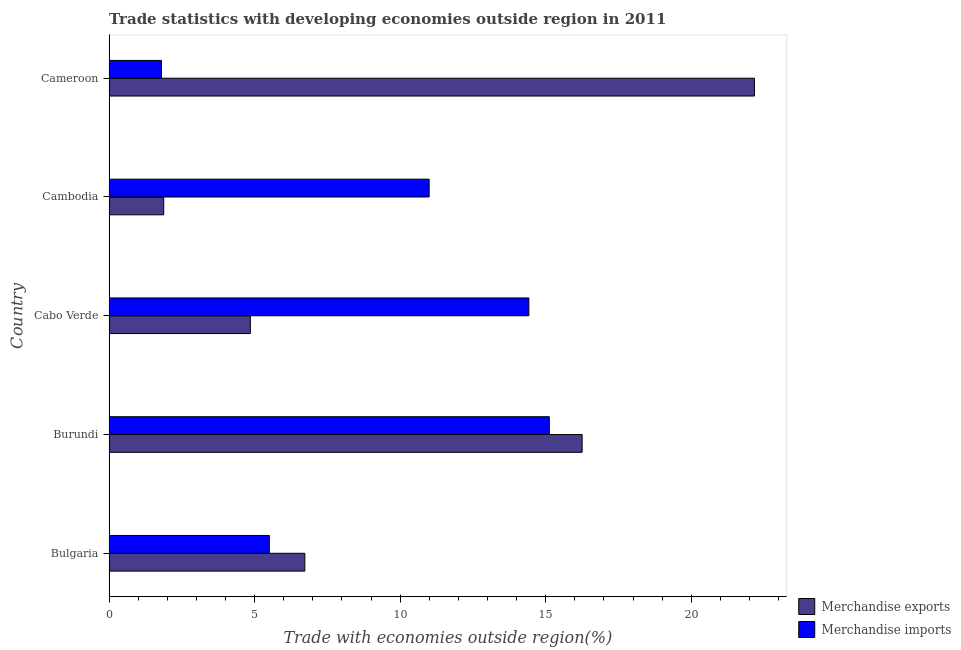How many groups of bars are there?
Your answer should be very brief. 5. Are the number of bars on each tick of the Y-axis equal?
Give a very brief answer. Yes. How many bars are there on the 1st tick from the top?
Your response must be concise. 2. How many bars are there on the 1st tick from the bottom?
Provide a short and direct response. 2. What is the label of the 4th group of bars from the top?
Provide a short and direct response. Burundi. What is the merchandise imports in Cambodia?
Provide a succinct answer. 11. Across all countries, what is the maximum merchandise exports?
Offer a very short reply. 22.17. Across all countries, what is the minimum merchandise exports?
Offer a terse response. 1.88. In which country was the merchandise exports maximum?
Keep it short and to the point. Cameroon. In which country was the merchandise imports minimum?
Your answer should be very brief. Cameroon. What is the total merchandise imports in the graph?
Make the answer very short. 47.85. What is the difference between the merchandise exports in Bulgaria and that in Cameroon?
Provide a short and direct response. -15.45. What is the difference between the merchandise exports in Cameroon and the merchandise imports in Cabo Verde?
Offer a very short reply. 7.75. What is the average merchandise imports per country?
Provide a succinct answer. 9.57. What is the difference between the merchandise exports and merchandise imports in Cambodia?
Make the answer very short. -9.12. In how many countries, is the merchandise exports greater than 7 %?
Your response must be concise. 2. What is the ratio of the merchandise exports in Burundi to that in Cambodia?
Provide a succinct answer. 8.66. Is the merchandise exports in Burundi less than that in Cameroon?
Make the answer very short. Yes. Is the difference between the merchandise imports in Burundi and Cambodia greater than the difference between the merchandise exports in Burundi and Cambodia?
Your response must be concise. No. What is the difference between the highest and the second highest merchandise exports?
Your answer should be very brief. 5.92. What is the difference between the highest and the lowest merchandise exports?
Your response must be concise. 20.29. Is the sum of the merchandise imports in Cabo Verde and Cameroon greater than the maximum merchandise exports across all countries?
Your answer should be compact. No. What does the 2nd bar from the top in Cambodia represents?
Offer a very short reply. Merchandise exports. What does the 2nd bar from the bottom in Bulgaria represents?
Offer a terse response. Merchandise imports. Where does the legend appear in the graph?
Your answer should be compact. Bottom right. How many legend labels are there?
Make the answer very short. 2. How are the legend labels stacked?
Give a very brief answer. Vertical. What is the title of the graph?
Provide a succinct answer. Trade statistics with developing economies outside region in 2011. What is the label or title of the X-axis?
Keep it short and to the point. Trade with economies outside region(%). What is the label or title of the Y-axis?
Your answer should be very brief. Country. What is the Trade with economies outside region(%) in Merchandise exports in Bulgaria?
Keep it short and to the point. 6.73. What is the Trade with economies outside region(%) in Merchandise imports in Bulgaria?
Ensure brevity in your answer.  5.51. What is the Trade with economies outside region(%) in Merchandise exports in Burundi?
Ensure brevity in your answer.  16.25. What is the Trade with economies outside region(%) in Merchandise imports in Burundi?
Your answer should be compact. 15.12. What is the Trade with economies outside region(%) in Merchandise exports in Cabo Verde?
Provide a short and direct response. 4.85. What is the Trade with economies outside region(%) in Merchandise imports in Cabo Verde?
Make the answer very short. 14.42. What is the Trade with economies outside region(%) of Merchandise exports in Cambodia?
Offer a terse response. 1.88. What is the Trade with economies outside region(%) of Merchandise imports in Cambodia?
Offer a very short reply. 11. What is the Trade with economies outside region(%) of Merchandise exports in Cameroon?
Keep it short and to the point. 22.17. What is the Trade with economies outside region(%) in Merchandise imports in Cameroon?
Your answer should be very brief. 1.8. Across all countries, what is the maximum Trade with economies outside region(%) in Merchandise exports?
Provide a short and direct response. 22.17. Across all countries, what is the maximum Trade with economies outside region(%) of Merchandise imports?
Your answer should be very brief. 15.12. Across all countries, what is the minimum Trade with economies outside region(%) in Merchandise exports?
Provide a short and direct response. 1.88. Across all countries, what is the minimum Trade with economies outside region(%) in Merchandise imports?
Give a very brief answer. 1.8. What is the total Trade with economies outside region(%) in Merchandise exports in the graph?
Your answer should be compact. 51.88. What is the total Trade with economies outside region(%) of Merchandise imports in the graph?
Your answer should be compact. 47.85. What is the difference between the Trade with economies outside region(%) of Merchandise exports in Bulgaria and that in Burundi?
Your response must be concise. -9.53. What is the difference between the Trade with economies outside region(%) of Merchandise imports in Bulgaria and that in Burundi?
Your answer should be very brief. -9.62. What is the difference between the Trade with economies outside region(%) in Merchandise exports in Bulgaria and that in Cabo Verde?
Provide a succinct answer. 1.87. What is the difference between the Trade with economies outside region(%) in Merchandise imports in Bulgaria and that in Cabo Verde?
Provide a succinct answer. -8.92. What is the difference between the Trade with economies outside region(%) in Merchandise exports in Bulgaria and that in Cambodia?
Provide a short and direct response. 4.85. What is the difference between the Trade with economies outside region(%) in Merchandise imports in Bulgaria and that in Cambodia?
Make the answer very short. -5.49. What is the difference between the Trade with economies outside region(%) of Merchandise exports in Bulgaria and that in Cameroon?
Provide a succinct answer. -15.45. What is the difference between the Trade with economies outside region(%) in Merchandise imports in Bulgaria and that in Cameroon?
Offer a very short reply. 3.71. What is the difference between the Trade with economies outside region(%) in Merchandise exports in Burundi and that in Cabo Verde?
Your response must be concise. 11.4. What is the difference between the Trade with economies outside region(%) of Merchandise imports in Burundi and that in Cabo Verde?
Make the answer very short. 0.7. What is the difference between the Trade with economies outside region(%) of Merchandise exports in Burundi and that in Cambodia?
Provide a succinct answer. 14.37. What is the difference between the Trade with economies outside region(%) of Merchandise imports in Burundi and that in Cambodia?
Make the answer very short. 4.13. What is the difference between the Trade with economies outside region(%) in Merchandise exports in Burundi and that in Cameroon?
Ensure brevity in your answer.  -5.92. What is the difference between the Trade with economies outside region(%) of Merchandise imports in Burundi and that in Cameroon?
Keep it short and to the point. 13.32. What is the difference between the Trade with economies outside region(%) in Merchandise exports in Cabo Verde and that in Cambodia?
Make the answer very short. 2.98. What is the difference between the Trade with economies outside region(%) in Merchandise imports in Cabo Verde and that in Cambodia?
Keep it short and to the point. 3.42. What is the difference between the Trade with economies outside region(%) of Merchandise exports in Cabo Verde and that in Cameroon?
Ensure brevity in your answer.  -17.32. What is the difference between the Trade with economies outside region(%) of Merchandise imports in Cabo Verde and that in Cameroon?
Offer a very short reply. 12.62. What is the difference between the Trade with economies outside region(%) of Merchandise exports in Cambodia and that in Cameroon?
Your response must be concise. -20.29. What is the difference between the Trade with economies outside region(%) of Merchandise imports in Cambodia and that in Cameroon?
Offer a very short reply. 9.2. What is the difference between the Trade with economies outside region(%) in Merchandise exports in Bulgaria and the Trade with economies outside region(%) in Merchandise imports in Burundi?
Your answer should be very brief. -8.4. What is the difference between the Trade with economies outside region(%) in Merchandise exports in Bulgaria and the Trade with economies outside region(%) in Merchandise imports in Cabo Verde?
Ensure brevity in your answer.  -7.7. What is the difference between the Trade with economies outside region(%) in Merchandise exports in Bulgaria and the Trade with economies outside region(%) in Merchandise imports in Cambodia?
Your answer should be compact. -4.27. What is the difference between the Trade with economies outside region(%) of Merchandise exports in Bulgaria and the Trade with economies outside region(%) of Merchandise imports in Cameroon?
Provide a succinct answer. 4.93. What is the difference between the Trade with economies outside region(%) of Merchandise exports in Burundi and the Trade with economies outside region(%) of Merchandise imports in Cabo Verde?
Offer a very short reply. 1.83. What is the difference between the Trade with economies outside region(%) in Merchandise exports in Burundi and the Trade with economies outside region(%) in Merchandise imports in Cambodia?
Make the answer very short. 5.26. What is the difference between the Trade with economies outside region(%) of Merchandise exports in Burundi and the Trade with economies outside region(%) of Merchandise imports in Cameroon?
Your answer should be very brief. 14.45. What is the difference between the Trade with economies outside region(%) in Merchandise exports in Cabo Verde and the Trade with economies outside region(%) in Merchandise imports in Cambodia?
Your answer should be very brief. -6.14. What is the difference between the Trade with economies outside region(%) of Merchandise exports in Cabo Verde and the Trade with economies outside region(%) of Merchandise imports in Cameroon?
Ensure brevity in your answer.  3.05. What is the difference between the Trade with economies outside region(%) of Merchandise exports in Cambodia and the Trade with economies outside region(%) of Merchandise imports in Cameroon?
Offer a terse response. 0.08. What is the average Trade with economies outside region(%) in Merchandise exports per country?
Provide a succinct answer. 10.38. What is the average Trade with economies outside region(%) of Merchandise imports per country?
Your answer should be compact. 9.57. What is the difference between the Trade with economies outside region(%) of Merchandise exports and Trade with economies outside region(%) of Merchandise imports in Bulgaria?
Offer a terse response. 1.22. What is the difference between the Trade with economies outside region(%) in Merchandise exports and Trade with economies outside region(%) in Merchandise imports in Burundi?
Ensure brevity in your answer.  1.13. What is the difference between the Trade with economies outside region(%) in Merchandise exports and Trade with economies outside region(%) in Merchandise imports in Cabo Verde?
Provide a short and direct response. -9.57. What is the difference between the Trade with economies outside region(%) in Merchandise exports and Trade with economies outside region(%) in Merchandise imports in Cambodia?
Your answer should be very brief. -9.12. What is the difference between the Trade with economies outside region(%) of Merchandise exports and Trade with economies outside region(%) of Merchandise imports in Cameroon?
Keep it short and to the point. 20.37. What is the ratio of the Trade with economies outside region(%) in Merchandise exports in Bulgaria to that in Burundi?
Your response must be concise. 0.41. What is the ratio of the Trade with economies outside region(%) in Merchandise imports in Bulgaria to that in Burundi?
Your answer should be compact. 0.36. What is the ratio of the Trade with economies outside region(%) of Merchandise exports in Bulgaria to that in Cabo Verde?
Provide a succinct answer. 1.39. What is the ratio of the Trade with economies outside region(%) of Merchandise imports in Bulgaria to that in Cabo Verde?
Make the answer very short. 0.38. What is the ratio of the Trade with economies outside region(%) of Merchandise exports in Bulgaria to that in Cambodia?
Give a very brief answer. 3.58. What is the ratio of the Trade with economies outside region(%) of Merchandise imports in Bulgaria to that in Cambodia?
Make the answer very short. 0.5. What is the ratio of the Trade with economies outside region(%) in Merchandise exports in Bulgaria to that in Cameroon?
Your response must be concise. 0.3. What is the ratio of the Trade with economies outside region(%) in Merchandise imports in Bulgaria to that in Cameroon?
Offer a terse response. 3.06. What is the ratio of the Trade with economies outside region(%) in Merchandise exports in Burundi to that in Cabo Verde?
Provide a succinct answer. 3.35. What is the ratio of the Trade with economies outside region(%) of Merchandise imports in Burundi to that in Cabo Verde?
Give a very brief answer. 1.05. What is the ratio of the Trade with economies outside region(%) in Merchandise exports in Burundi to that in Cambodia?
Make the answer very short. 8.66. What is the ratio of the Trade with economies outside region(%) in Merchandise imports in Burundi to that in Cambodia?
Offer a very short reply. 1.38. What is the ratio of the Trade with economies outside region(%) of Merchandise exports in Burundi to that in Cameroon?
Your answer should be compact. 0.73. What is the ratio of the Trade with economies outside region(%) in Merchandise imports in Burundi to that in Cameroon?
Offer a terse response. 8.4. What is the ratio of the Trade with economies outside region(%) in Merchandise exports in Cabo Verde to that in Cambodia?
Your answer should be very brief. 2.58. What is the ratio of the Trade with economies outside region(%) of Merchandise imports in Cabo Verde to that in Cambodia?
Provide a short and direct response. 1.31. What is the ratio of the Trade with economies outside region(%) of Merchandise exports in Cabo Verde to that in Cameroon?
Offer a very short reply. 0.22. What is the ratio of the Trade with economies outside region(%) of Merchandise imports in Cabo Verde to that in Cameroon?
Provide a short and direct response. 8.01. What is the ratio of the Trade with economies outside region(%) in Merchandise exports in Cambodia to that in Cameroon?
Make the answer very short. 0.08. What is the ratio of the Trade with economies outside region(%) of Merchandise imports in Cambodia to that in Cameroon?
Your answer should be very brief. 6.11. What is the difference between the highest and the second highest Trade with economies outside region(%) in Merchandise exports?
Keep it short and to the point. 5.92. What is the difference between the highest and the second highest Trade with economies outside region(%) in Merchandise imports?
Provide a short and direct response. 0.7. What is the difference between the highest and the lowest Trade with economies outside region(%) of Merchandise exports?
Your response must be concise. 20.29. What is the difference between the highest and the lowest Trade with economies outside region(%) of Merchandise imports?
Provide a short and direct response. 13.32. 